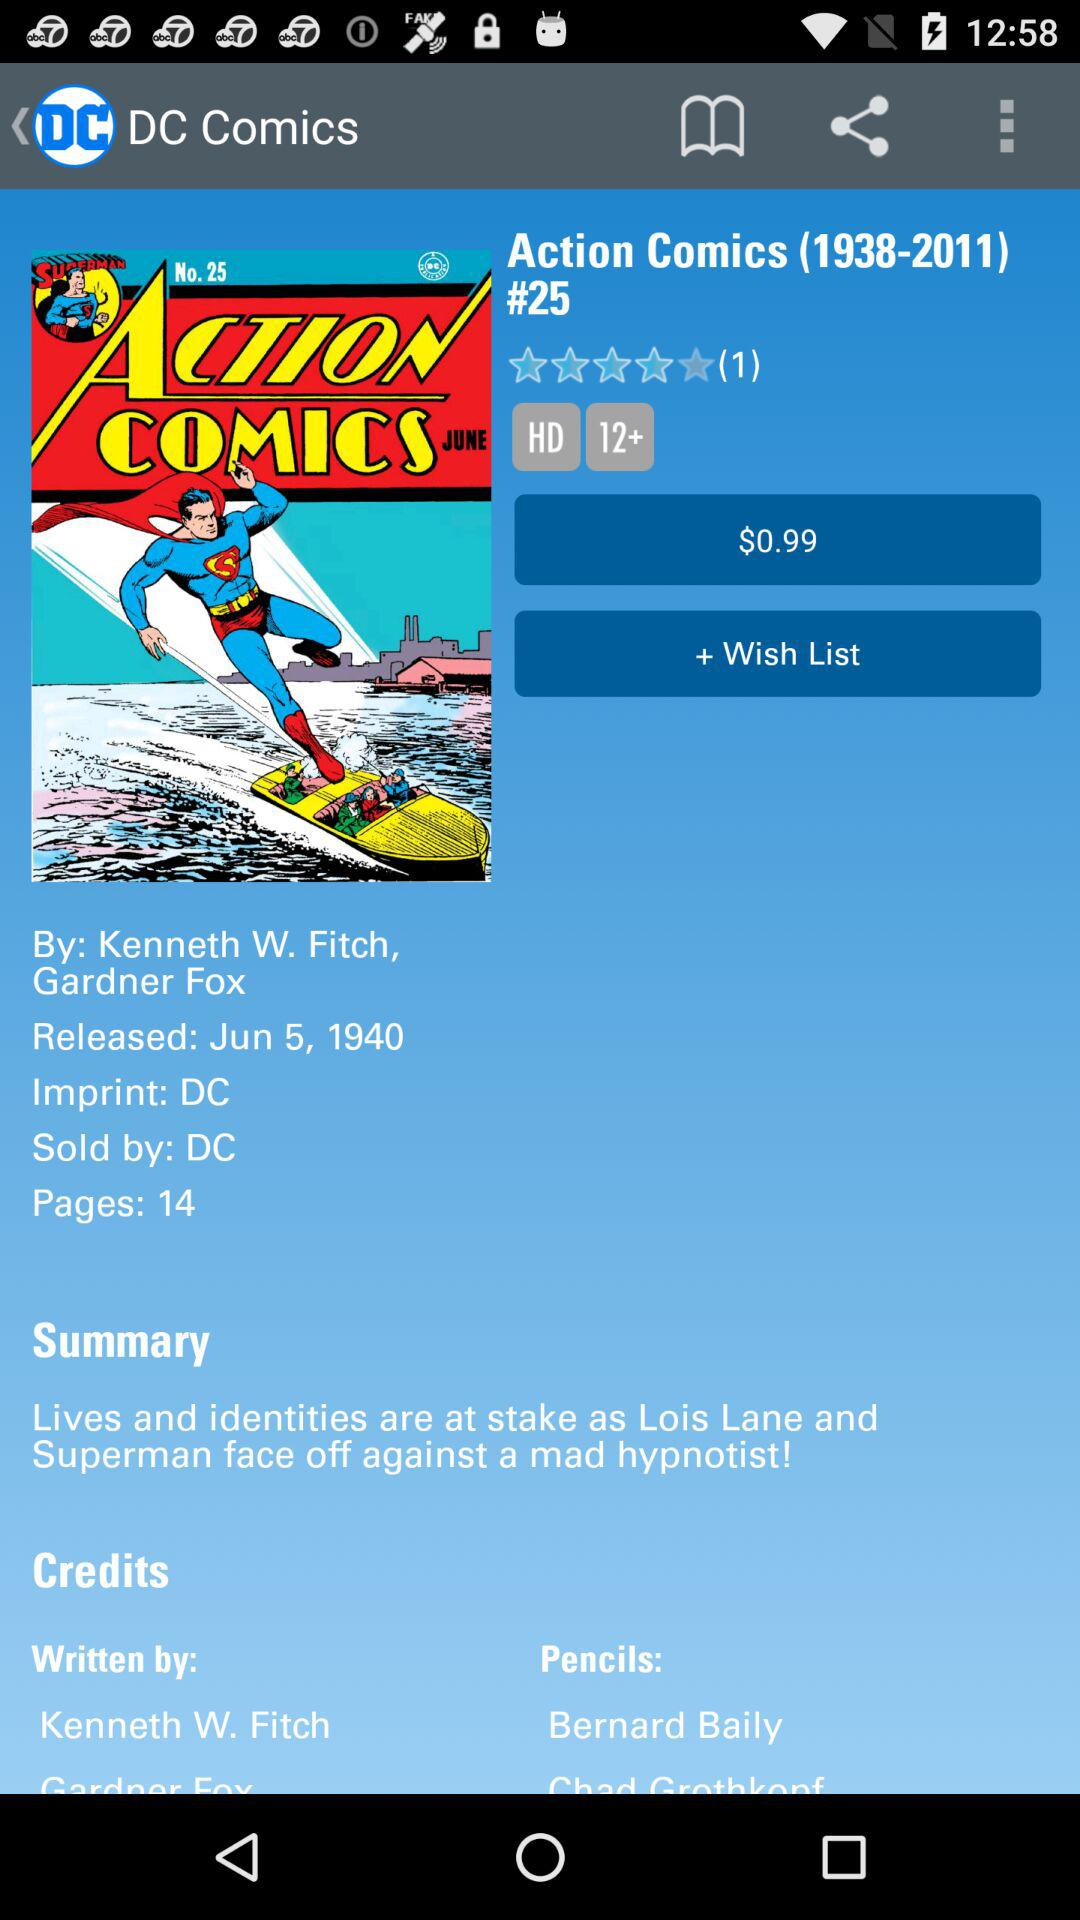What is the rating of the Action Comics? The rating is 4 stars. 